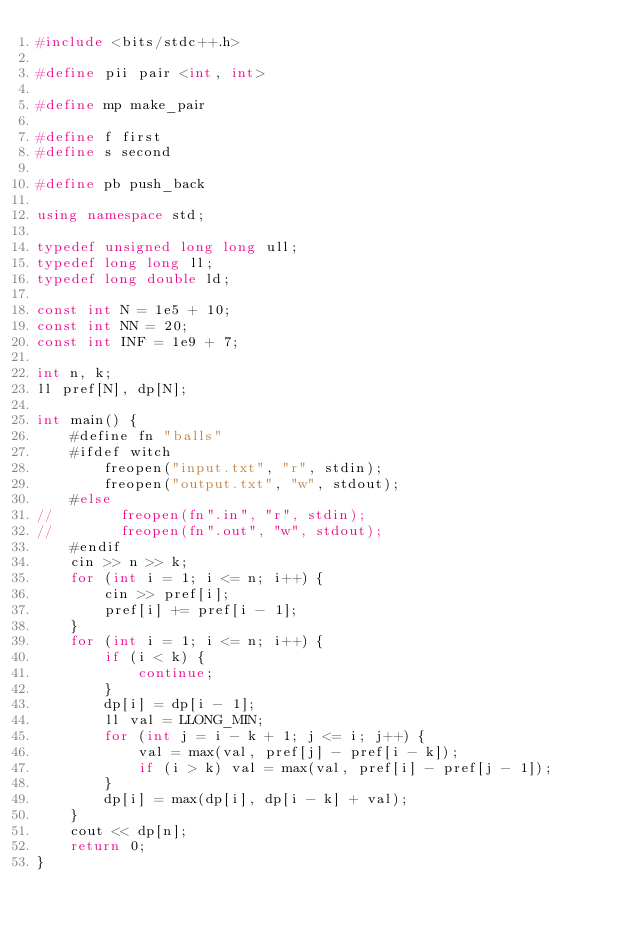Convert code to text. <code><loc_0><loc_0><loc_500><loc_500><_C++_>#include <bits/stdc++.h>

#define pii pair <int, int>

#define mp make_pair

#define f first
#define s second

#define pb push_back

using namespace std;

typedef unsigned long long ull;
typedef long long ll;
typedef long double ld;

const int N = 1e5 + 10;
const int NN = 20;
const int INF = 1e9 + 7;

int n, k;
ll pref[N], dp[N];

int main() {
    #define fn "balls"
    #ifdef witch
        freopen("input.txt", "r", stdin);
        freopen("output.txt", "w", stdout);
    #else
//        freopen(fn".in", "r", stdin);
//        freopen(fn".out", "w", stdout);
    #endif
    cin >> n >> k;
    for (int i = 1; i <= n; i++) {
        cin >> pref[i];
        pref[i] += pref[i - 1];
    }
    for (int i = 1; i <= n; i++) {
        if (i < k) {
            continue;
        }
        dp[i] = dp[i - 1];
        ll val = LLONG_MIN;
        for (int j = i - k + 1; j <= i; j++) {
            val = max(val, pref[j] - pref[i - k]);
            if (i > k) val = max(val, pref[i] - pref[j - 1]);
        }
        dp[i] = max(dp[i], dp[i - k] + val);
    }
    cout << dp[n];
    return 0;
}</code> 